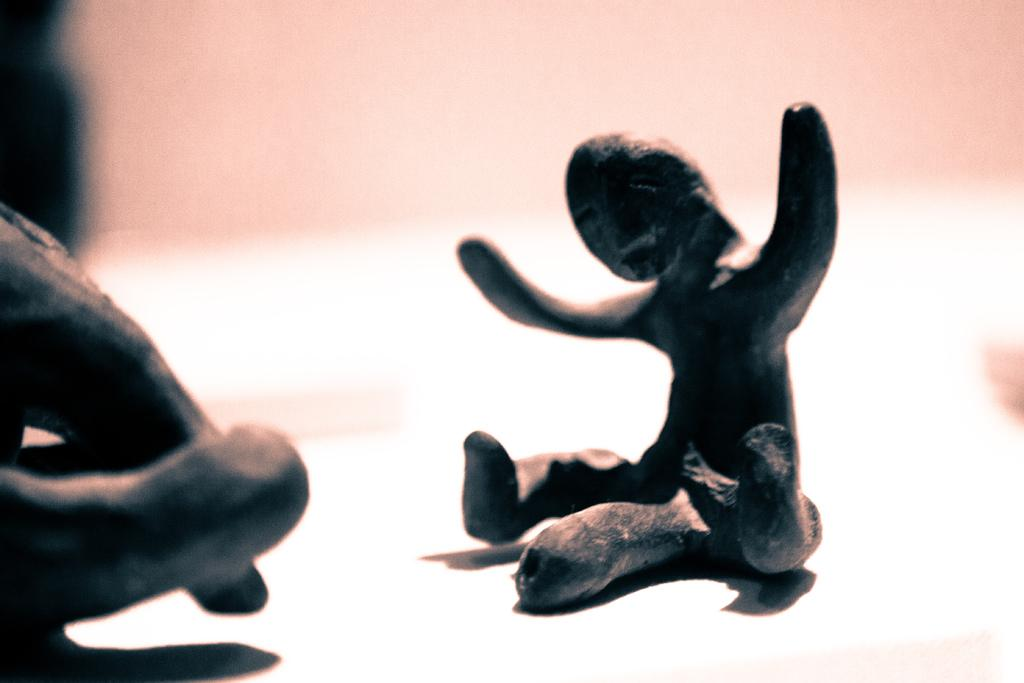What is the main subject in the image? There is a carved stone in the image. Can you describe the background of the image? The background of the image is blurry. What type of pain is the carved stone experiencing in the image? The carved stone is not capable of experiencing pain, as it is an inanimate object. 